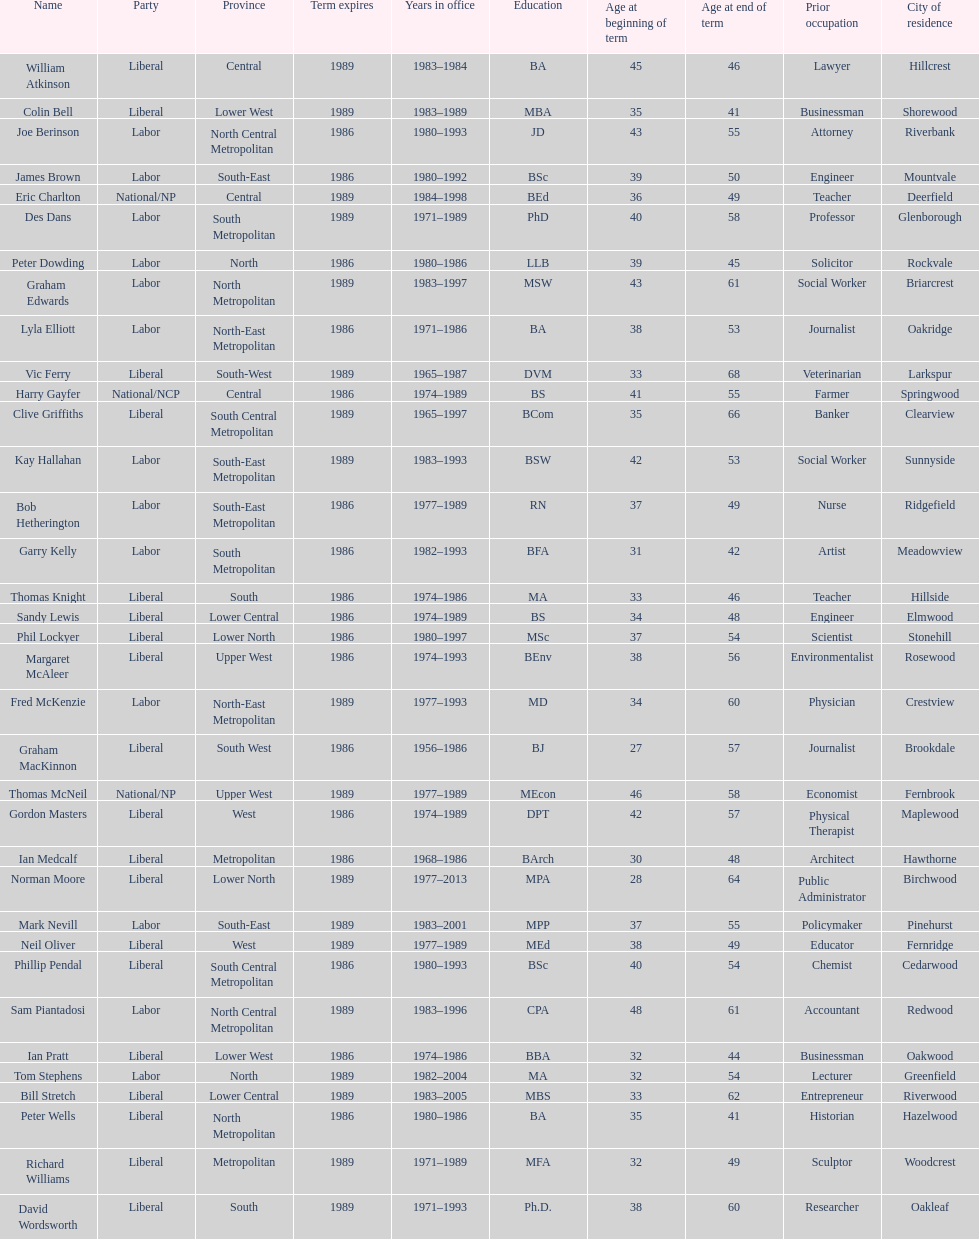What is the number of people in the liberal party? 19. 